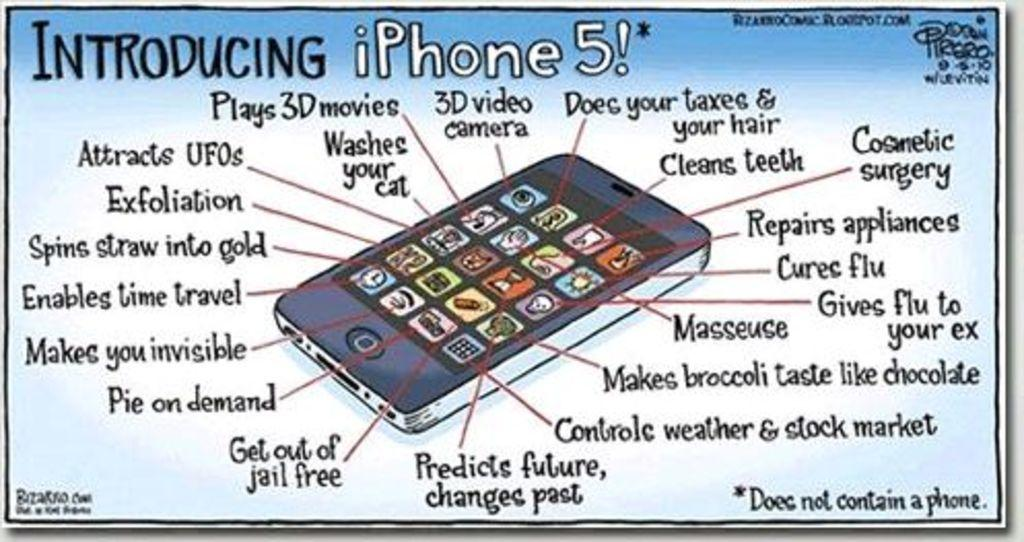<image>
Render a clear and concise summary of the photo. A cartoon about the features of the iPhone 5. 